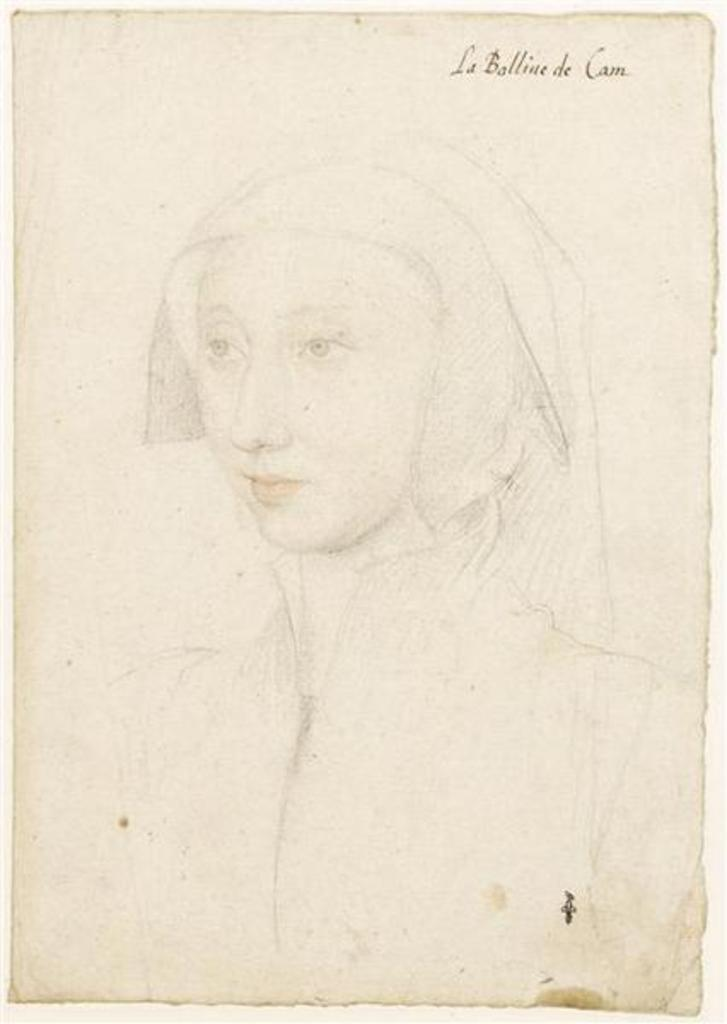What type of artwork is shown in the image? The image appears to be a painting. Who or what is the main subject of the painting? There is a woman depicted in the painting. Are there any words or letters in the painting? Yes, there is text present in the painting. Where is the frog sitting in the painting? There is no frog present in the painting. What type of market is shown in the painting? There is no market depicted in the painting; it features a woman and text. 